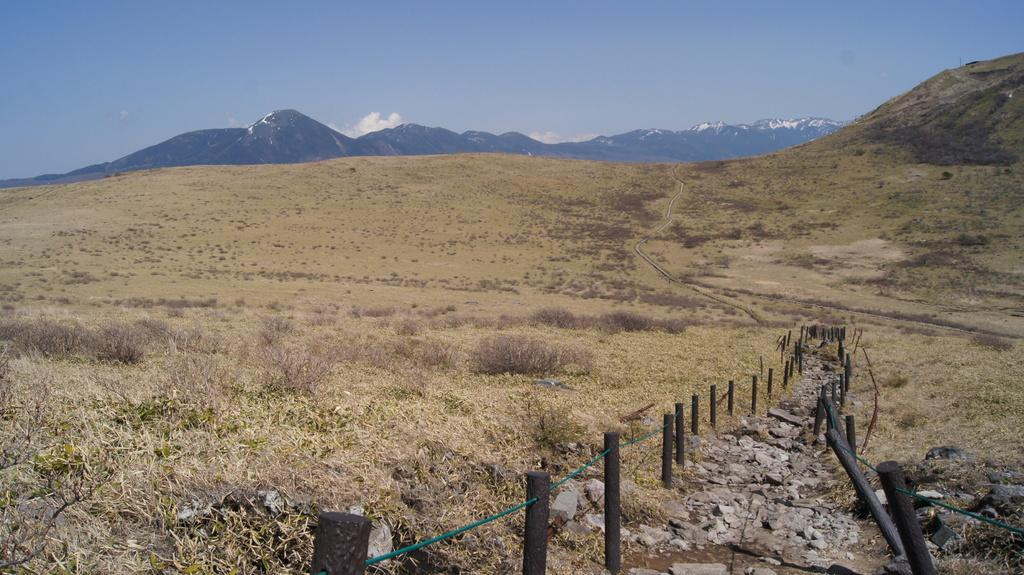What type of terrain is shown in the image? The image depicts an open land covered with grass. Is there any specific feature in the middle of the open land? Yes, there is a path filled with stones in the middle of the open land. What can be seen in the background of the image? In the background, there are many mountains. How many crates are visible on the path in the image? There are no crates visible on the path in the image. What is the distance between the mountains in the background? The distance between the mountains in the background cannot be determined from the image alone. 